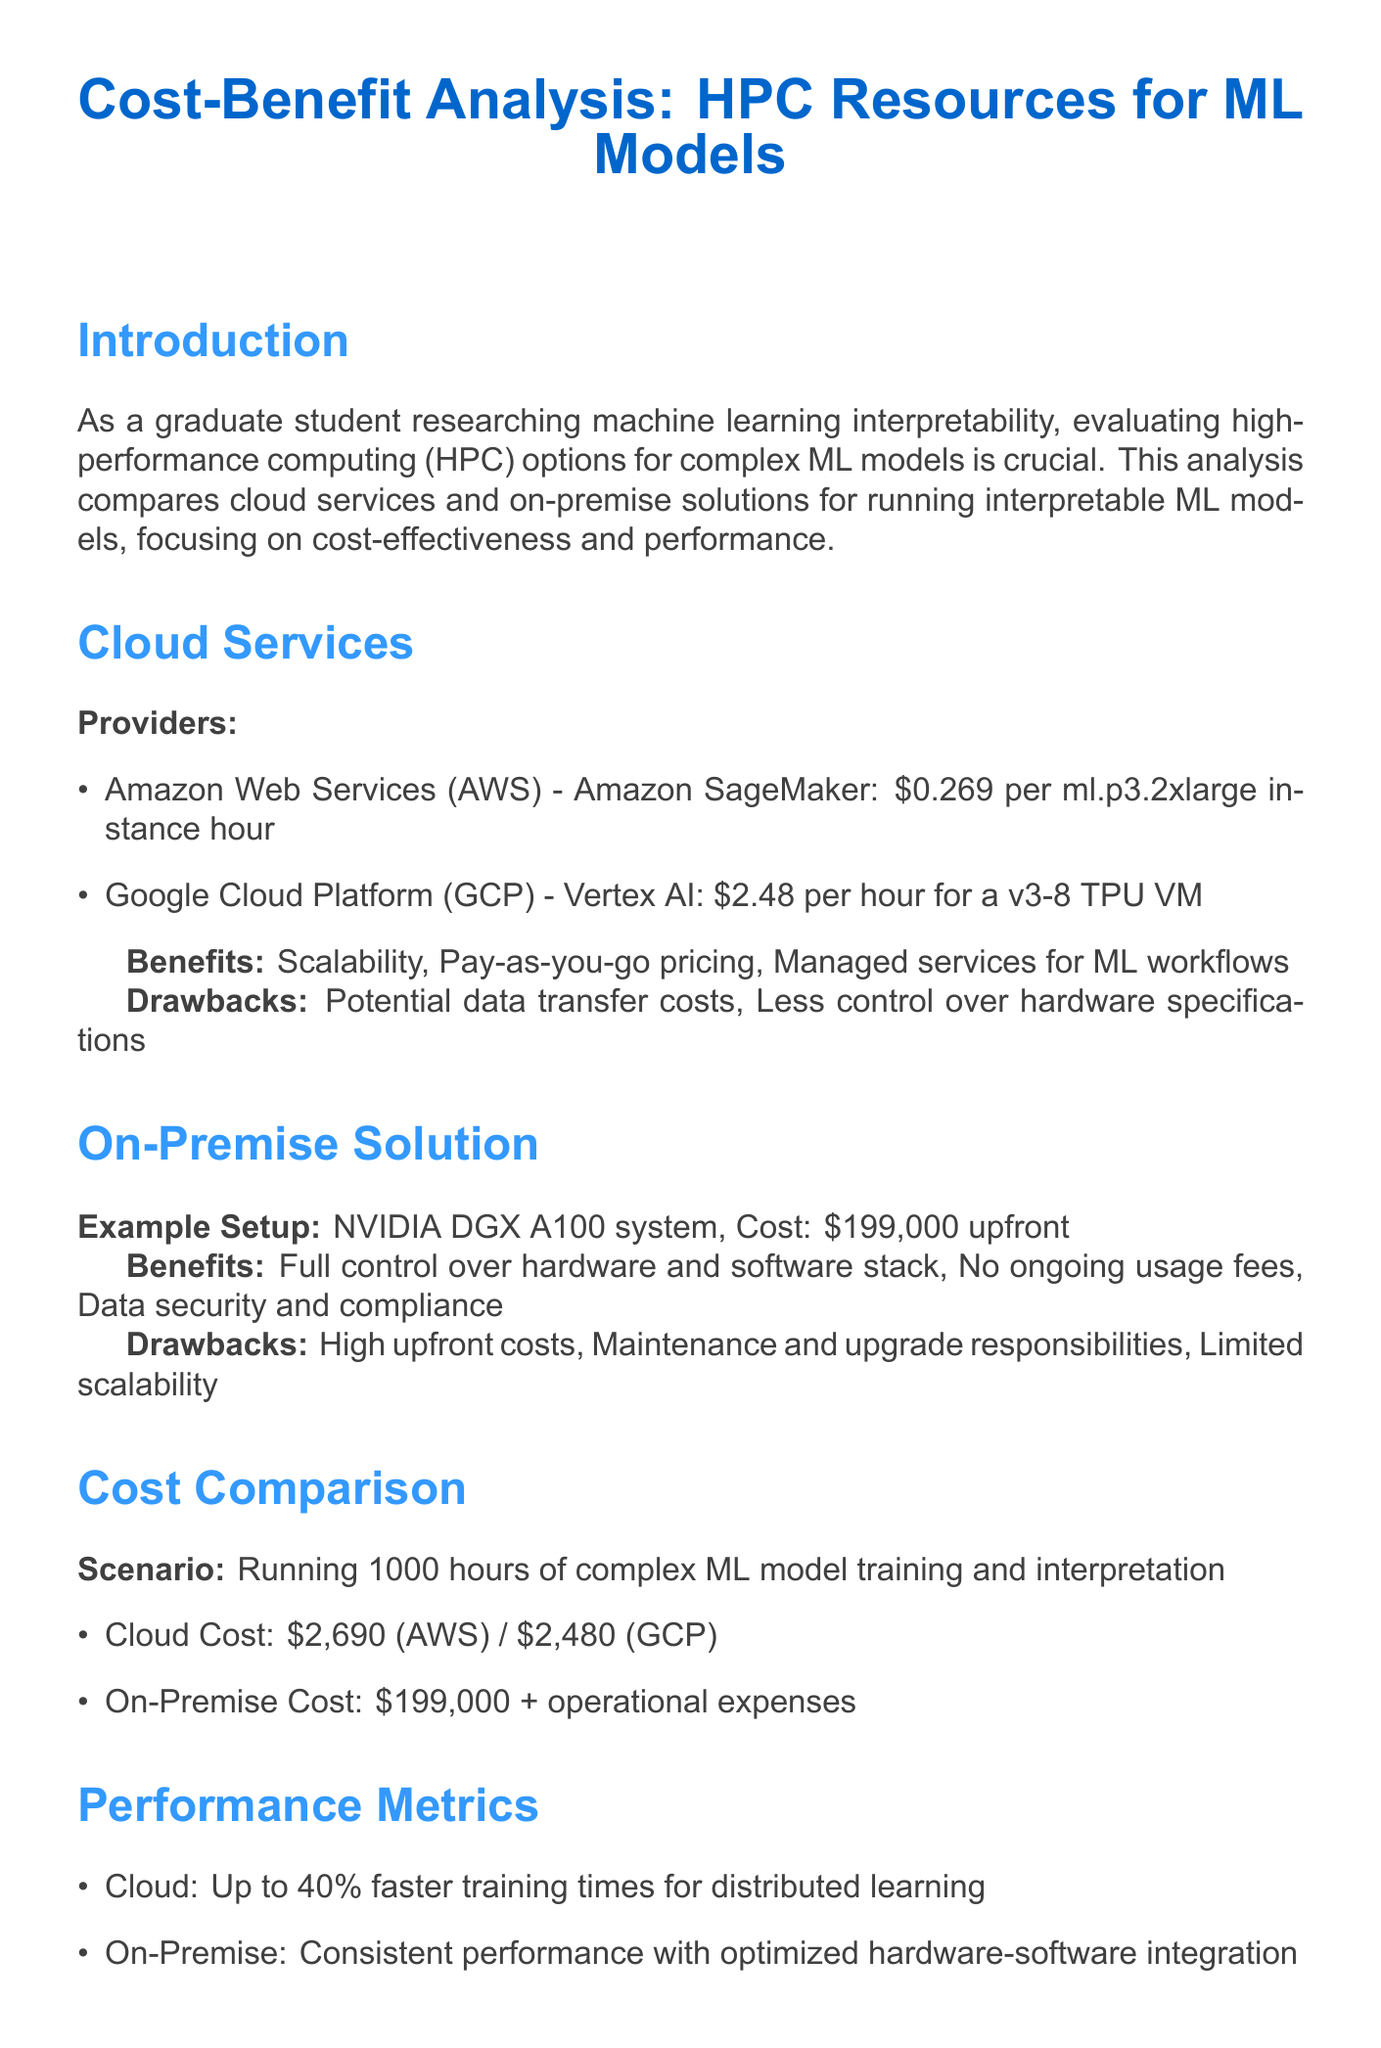What is the cost of AWS per instance hour? The document specifies the cost of the AWS offering (Amazon SageMaker) as $0.269 per ml.p3.2xlarge instance hour.
Answer: $0.269 What is the on-premise solution's hardware setup? The document states that the example setup for the on-premise solution is an NVIDIA DGX A100 system.
Answer: NVIDIA DGX A100 system What is the short-term recommendation for HPC resource usage? The short-term recommendation advises utilizing cloud services for flexibility and cost-effectiveness in the research phase.
Answer: Utilize cloud services How much does it cost to run ML model training on GCP for 1000 hours? The document indicates that running ML models on GCP for 1000 hours costs $2,480.
Answer: $2,480 What benefit does cloud service offer regarding usage fees? The document mentions that cloud services provide pay-as-you-go pricing as a benefit.
Answer: Pay-as-you-go pricing What is the upfront cost of the on-premise solution? It is stated in the document that the upfront cost for the on-premise solution is $199,000.
Answer: $199,000 What is a drawback of using cloud services? The document lists potential data transfer costs as a drawback of using cloud services.
Answer: Potential data transfer costs What is the estimated performance difference in training times provided by cloud resources? The document notes that cloud resources can result in up to 40% faster training times for distributed learning.
Answer: Up to 40% What is the primary focus of this cost-benefit analysis document? The document clarifies that its objective is to compare cloud services and on-premise solutions for running interpretable ML models.
Answer: Compare cloud services and on-premise solutions 